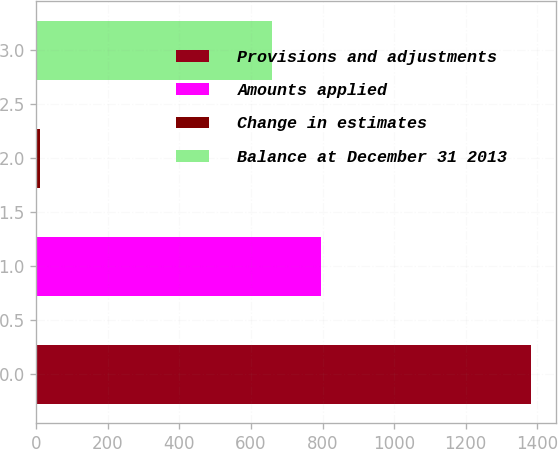Convert chart to OTSL. <chart><loc_0><loc_0><loc_500><loc_500><bar_chart><fcel>Provisions and adjustments<fcel>Amounts applied<fcel>Change in estimates<fcel>Balance at December 31 2013<nl><fcel>1383<fcel>795.4<fcel>9<fcel>658<nl></chart> 